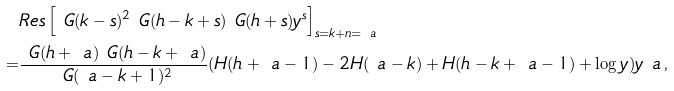Convert formula to latex. <formula><loc_0><loc_0><loc_500><loc_500>& R e s \left [ \ G ( k - s ) ^ { 2 } \ G ( h - k + s ) \ G ( h + s ) y ^ { s } \right ] _ { s = k + n = \ a } \\ = & \frac { \ G ( h + \ a ) \ G ( h - k + \ a ) } { \ G ( \ a - k + 1 ) ^ { 2 } } ( H ( h + \ a - 1 ) - 2 H ( \ a - k ) + H ( h - k + \ a - 1 ) + \log y ) y ^ { \ } a \, ,</formula> 